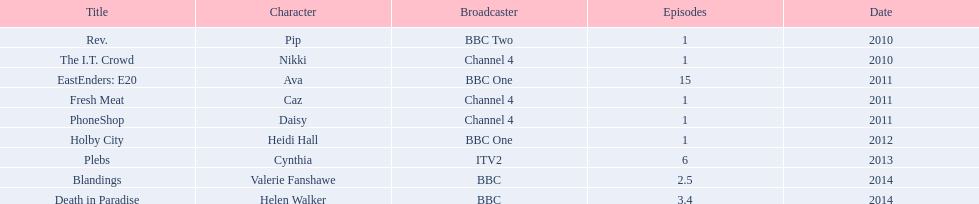Which characters had roles in several episodes? Ava, Cynthia, Valerie Fanshawe, Helen Walker. Who from this group was not featured in 2014? Ava, Cynthia. And which character wasn't part of a bbc broadcast? Cynthia. 